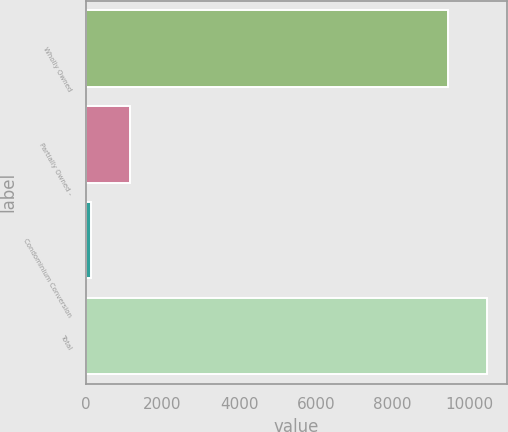<chart> <loc_0><loc_0><loc_500><loc_500><bar_chart><fcel>Wholly Owned<fcel>Partially Owned -<fcel>Condominium Conversion<fcel>Total<nl><fcel>9457<fcel>1142.7<fcel>130<fcel>10469.7<nl></chart> 